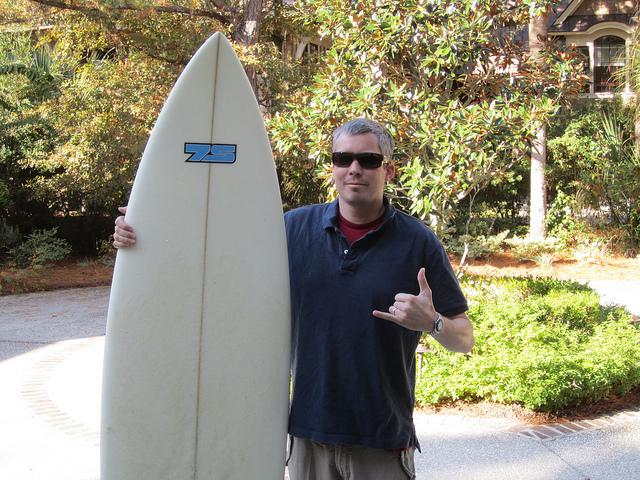What are the letters on the skateboard?
Write a very short answer. Zs. What object is the man holding with his right arm?
Concise answer only. Surfboard. Is the guy wearing sunglasses?
Be succinct. Yes. 